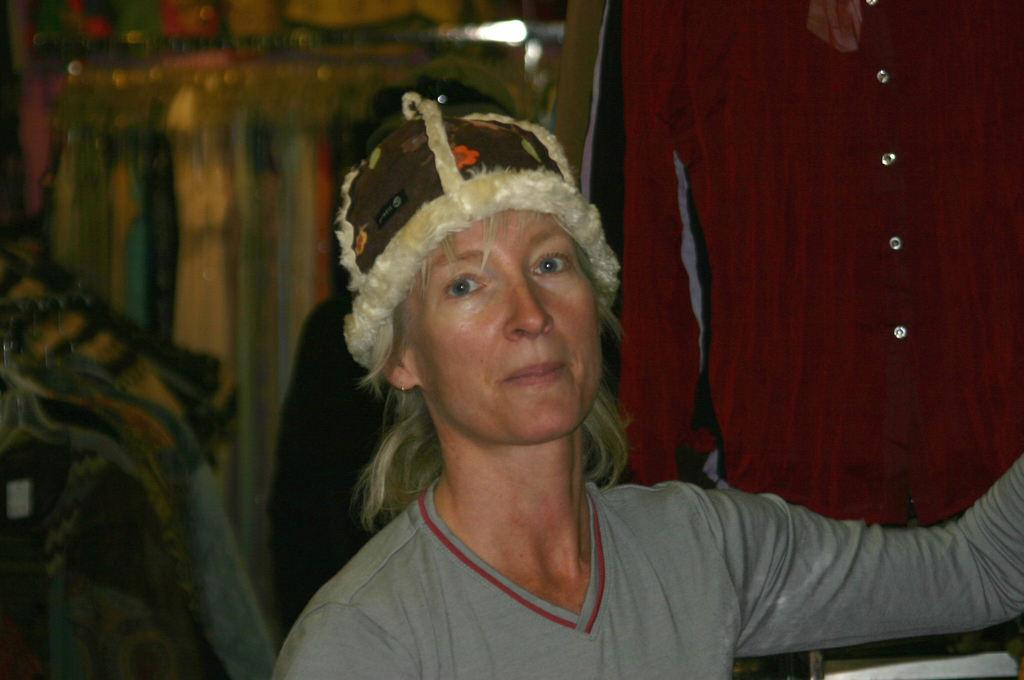Who is in the image? There is a person in the image. What is the person wearing? The person is wearing a grey dress and a hat. What can be seen behind the person? There are clothes hanged behind the person. How would you describe the background of the image? The background of the image is blurry. What type of stranger can be seen interacting with the person in the image? There is no stranger present in the image; it only features one person. What scene is taking place during recess in the image? The image does not depict a scene during recess, nor is there any indication of a recess-related activity. 